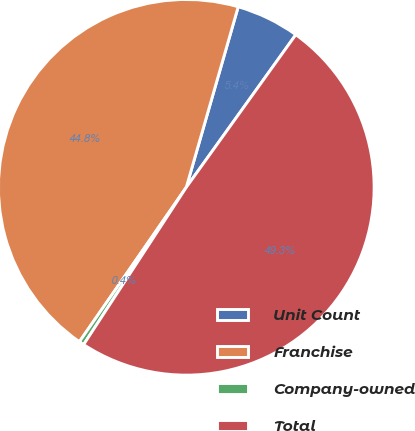Convert chart to OTSL. <chart><loc_0><loc_0><loc_500><loc_500><pie_chart><fcel>Unit Count<fcel>Franchise<fcel>Company-owned<fcel>Total<nl><fcel>5.45%<fcel>44.82%<fcel>0.43%<fcel>49.3%<nl></chart> 